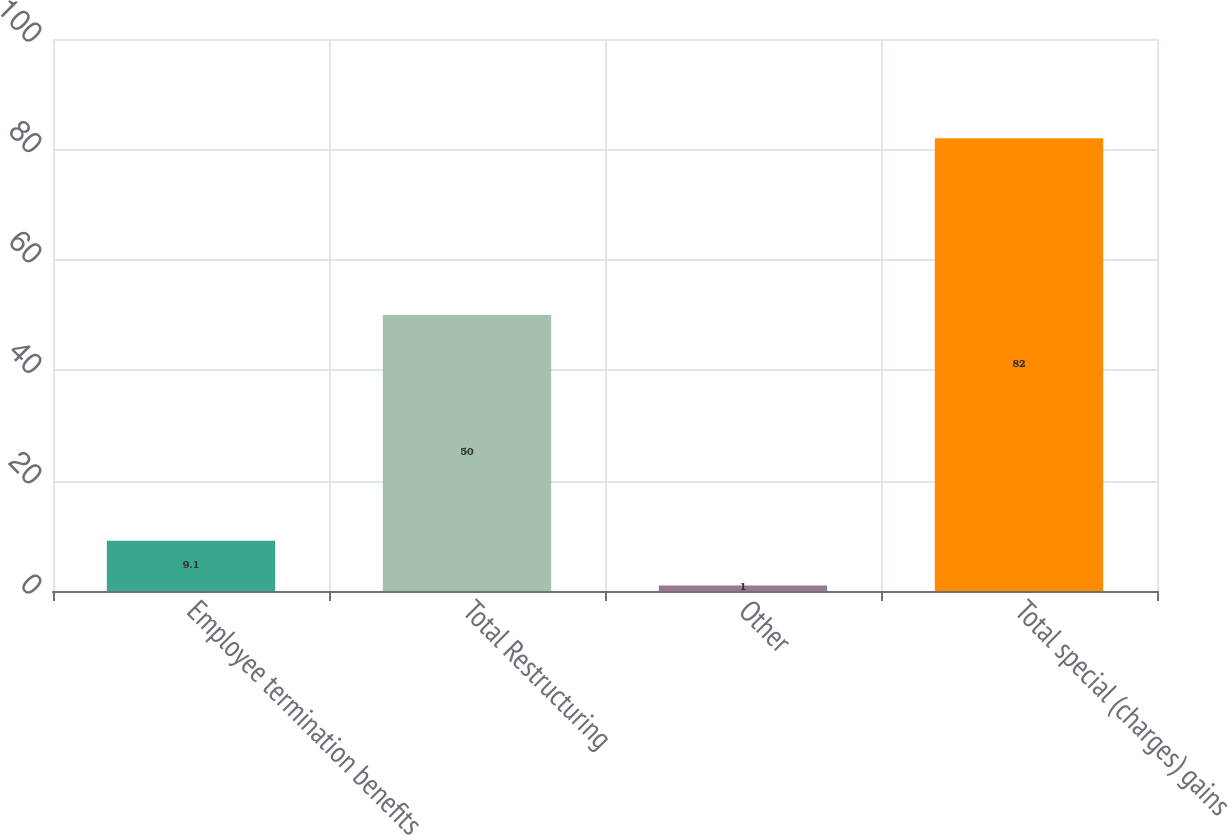Convert chart to OTSL. <chart><loc_0><loc_0><loc_500><loc_500><bar_chart><fcel>Employee termination benefits<fcel>Total Restructuring<fcel>Other<fcel>Total special (charges) gains<nl><fcel>9.1<fcel>50<fcel>1<fcel>82<nl></chart> 